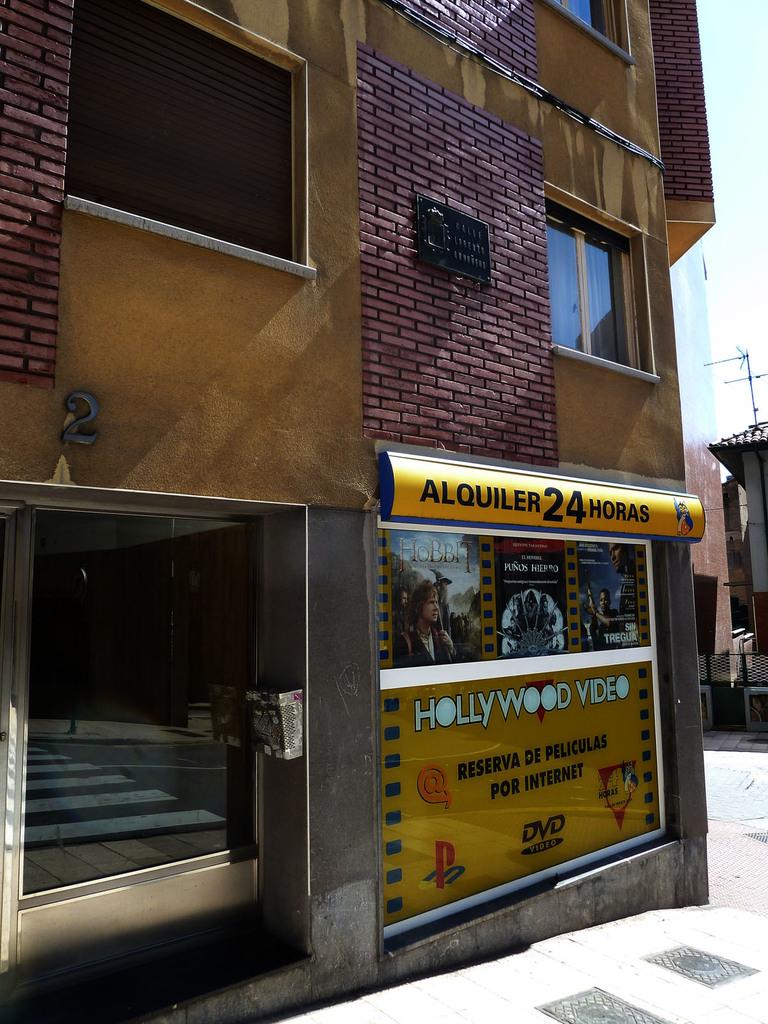How many hours is this shop open?
Provide a short and direct response. 24. What kind of movies does this place sell?
Keep it short and to the point. Unanswerable. 